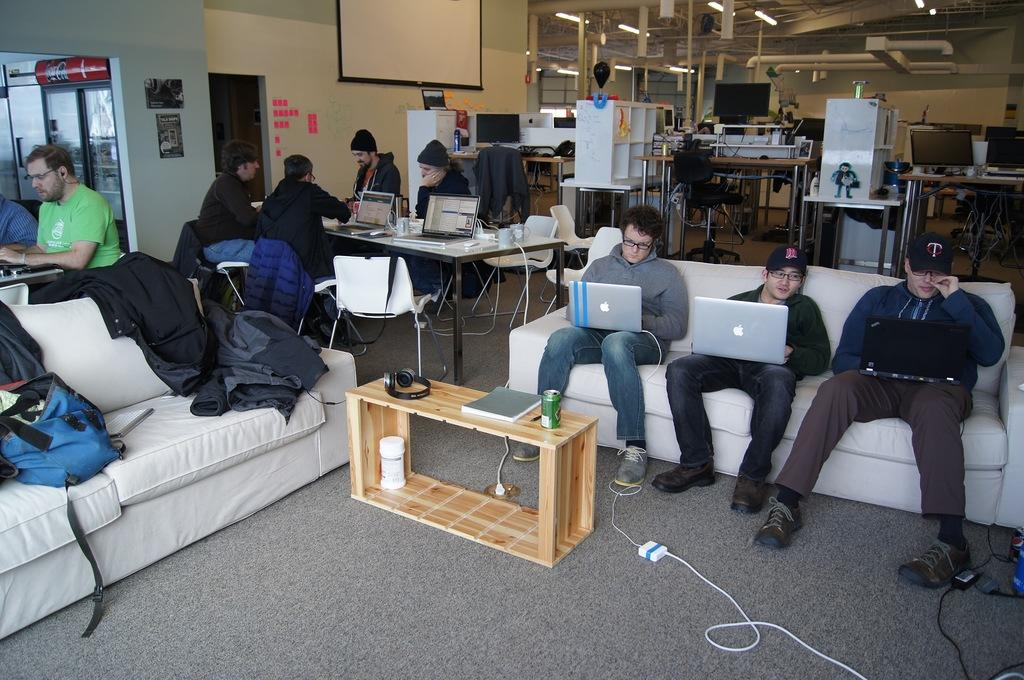Who is present in the image? There are people in the image. What are the people doing in the image? The people are sitting on sofas and chairs. What objects can be seen on the table in the image? There are laptops on a table in front of some people. How are some people using their laptops in the image? Some people have laptops on their laps. What type of brass material can be seen on the edge of the desk in the image? There is no desk or brass material present in the image. 